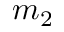<formula> <loc_0><loc_0><loc_500><loc_500>m _ { 2 }</formula> 